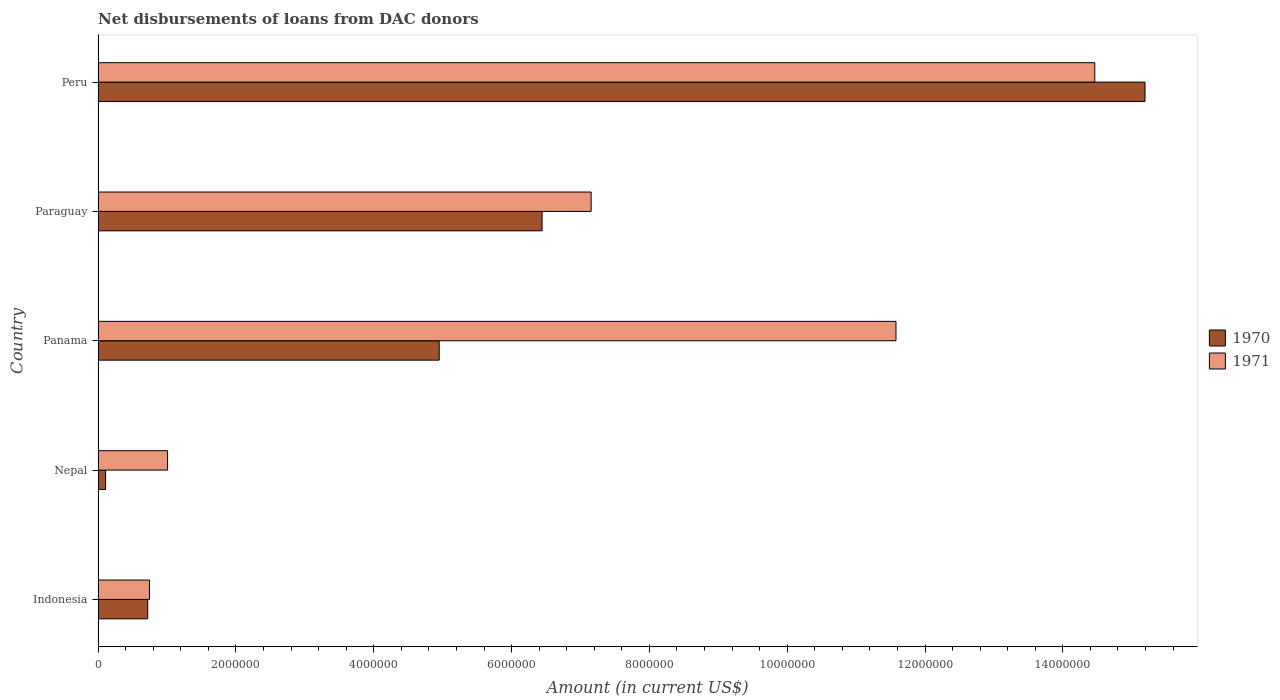How many different coloured bars are there?
Give a very brief answer. 2. Are the number of bars per tick equal to the number of legend labels?
Your response must be concise. Yes. How many bars are there on the 1st tick from the bottom?
Keep it short and to the point. 2. What is the label of the 3rd group of bars from the top?
Make the answer very short. Panama. In how many cases, is the number of bars for a given country not equal to the number of legend labels?
Your response must be concise. 0. What is the amount of loans disbursed in 1970 in Peru?
Give a very brief answer. 1.52e+07. Across all countries, what is the maximum amount of loans disbursed in 1970?
Your answer should be compact. 1.52e+07. Across all countries, what is the minimum amount of loans disbursed in 1971?
Make the answer very short. 7.45e+05. In which country was the amount of loans disbursed in 1971 minimum?
Offer a terse response. Indonesia. What is the total amount of loans disbursed in 1970 in the graph?
Offer a very short reply. 2.74e+07. What is the difference between the amount of loans disbursed in 1971 in Nepal and that in Paraguay?
Provide a succinct answer. -6.15e+06. What is the difference between the amount of loans disbursed in 1970 in Indonesia and the amount of loans disbursed in 1971 in Peru?
Ensure brevity in your answer.  -1.37e+07. What is the average amount of loans disbursed in 1970 per country?
Provide a short and direct response. 5.48e+06. What is the difference between the amount of loans disbursed in 1970 and amount of loans disbursed in 1971 in Nepal?
Offer a terse response. -8.99e+05. In how many countries, is the amount of loans disbursed in 1970 greater than 12400000 US$?
Make the answer very short. 1. What is the ratio of the amount of loans disbursed in 1970 in Indonesia to that in Paraguay?
Your answer should be very brief. 0.11. Is the amount of loans disbursed in 1971 in Nepal less than that in Panama?
Provide a succinct answer. Yes. Is the difference between the amount of loans disbursed in 1970 in Paraguay and Peru greater than the difference between the amount of loans disbursed in 1971 in Paraguay and Peru?
Your answer should be very brief. No. What is the difference between the highest and the second highest amount of loans disbursed in 1971?
Keep it short and to the point. 2.88e+06. What is the difference between the highest and the lowest amount of loans disbursed in 1971?
Provide a succinct answer. 1.37e+07. What does the 2nd bar from the bottom in Nepal represents?
Ensure brevity in your answer.  1971. Are all the bars in the graph horizontal?
Your answer should be very brief. Yes. How many countries are there in the graph?
Provide a succinct answer. 5. Are the values on the major ticks of X-axis written in scientific E-notation?
Your answer should be compact. No. Does the graph contain grids?
Offer a very short reply. No. Where does the legend appear in the graph?
Offer a terse response. Center right. How many legend labels are there?
Give a very brief answer. 2. How are the legend labels stacked?
Make the answer very short. Vertical. What is the title of the graph?
Your answer should be very brief. Net disbursements of loans from DAC donors. What is the label or title of the X-axis?
Provide a short and direct response. Amount (in current US$). What is the Amount (in current US$) of 1970 in Indonesia?
Ensure brevity in your answer.  7.20e+05. What is the Amount (in current US$) of 1971 in Indonesia?
Provide a succinct answer. 7.45e+05. What is the Amount (in current US$) of 1970 in Nepal?
Provide a succinct answer. 1.09e+05. What is the Amount (in current US$) of 1971 in Nepal?
Provide a succinct answer. 1.01e+06. What is the Amount (in current US$) in 1970 in Panama?
Your answer should be compact. 4.95e+06. What is the Amount (in current US$) of 1971 in Panama?
Offer a terse response. 1.16e+07. What is the Amount (in current US$) of 1970 in Paraguay?
Make the answer very short. 6.44e+06. What is the Amount (in current US$) in 1971 in Paraguay?
Provide a succinct answer. 7.16e+06. What is the Amount (in current US$) in 1970 in Peru?
Offer a very short reply. 1.52e+07. What is the Amount (in current US$) of 1971 in Peru?
Your response must be concise. 1.45e+07. Across all countries, what is the maximum Amount (in current US$) of 1970?
Ensure brevity in your answer.  1.52e+07. Across all countries, what is the maximum Amount (in current US$) in 1971?
Ensure brevity in your answer.  1.45e+07. Across all countries, what is the minimum Amount (in current US$) of 1970?
Make the answer very short. 1.09e+05. Across all countries, what is the minimum Amount (in current US$) in 1971?
Your response must be concise. 7.45e+05. What is the total Amount (in current US$) in 1970 in the graph?
Give a very brief answer. 2.74e+07. What is the total Amount (in current US$) of 1971 in the graph?
Provide a succinct answer. 3.50e+07. What is the difference between the Amount (in current US$) of 1970 in Indonesia and that in Nepal?
Your response must be concise. 6.11e+05. What is the difference between the Amount (in current US$) in 1971 in Indonesia and that in Nepal?
Your response must be concise. -2.63e+05. What is the difference between the Amount (in current US$) in 1970 in Indonesia and that in Panama?
Keep it short and to the point. -4.23e+06. What is the difference between the Amount (in current US$) of 1971 in Indonesia and that in Panama?
Give a very brief answer. -1.08e+07. What is the difference between the Amount (in current US$) in 1970 in Indonesia and that in Paraguay?
Offer a terse response. -5.72e+06. What is the difference between the Amount (in current US$) in 1971 in Indonesia and that in Paraguay?
Offer a terse response. -6.41e+06. What is the difference between the Amount (in current US$) in 1970 in Indonesia and that in Peru?
Offer a very short reply. -1.45e+07. What is the difference between the Amount (in current US$) of 1971 in Indonesia and that in Peru?
Provide a succinct answer. -1.37e+07. What is the difference between the Amount (in current US$) in 1970 in Nepal and that in Panama?
Make the answer very short. -4.84e+06. What is the difference between the Amount (in current US$) of 1971 in Nepal and that in Panama?
Your answer should be compact. -1.06e+07. What is the difference between the Amount (in current US$) in 1970 in Nepal and that in Paraguay?
Your response must be concise. -6.33e+06. What is the difference between the Amount (in current US$) of 1971 in Nepal and that in Paraguay?
Provide a succinct answer. -6.15e+06. What is the difference between the Amount (in current US$) in 1970 in Nepal and that in Peru?
Provide a succinct answer. -1.51e+07. What is the difference between the Amount (in current US$) in 1971 in Nepal and that in Peru?
Offer a terse response. -1.35e+07. What is the difference between the Amount (in current US$) in 1970 in Panama and that in Paraguay?
Ensure brevity in your answer.  -1.49e+06. What is the difference between the Amount (in current US$) of 1971 in Panama and that in Paraguay?
Offer a terse response. 4.42e+06. What is the difference between the Amount (in current US$) in 1970 in Panama and that in Peru?
Provide a short and direct response. -1.02e+07. What is the difference between the Amount (in current US$) of 1971 in Panama and that in Peru?
Make the answer very short. -2.88e+06. What is the difference between the Amount (in current US$) of 1970 in Paraguay and that in Peru?
Give a very brief answer. -8.75e+06. What is the difference between the Amount (in current US$) in 1971 in Paraguay and that in Peru?
Offer a terse response. -7.31e+06. What is the difference between the Amount (in current US$) of 1970 in Indonesia and the Amount (in current US$) of 1971 in Nepal?
Provide a succinct answer. -2.88e+05. What is the difference between the Amount (in current US$) of 1970 in Indonesia and the Amount (in current US$) of 1971 in Panama?
Your answer should be very brief. -1.09e+07. What is the difference between the Amount (in current US$) in 1970 in Indonesia and the Amount (in current US$) in 1971 in Paraguay?
Offer a terse response. -6.44e+06. What is the difference between the Amount (in current US$) in 1970 in Indonesia and the Amount (in current US$) in 1971 in Peru?
Provide a short and direct response. -1.37e+07. What is the difference between the Amount (in current US$) in 1970 in Nepal and the Amount (in current US$) in 1971 in Panama?
Keep it short and to the point. -1.15e+07. What is the difference between the Amount (in current US$) in 1970 in Nepal and the Amount (in current US$) in 1971 in Paraguay?
Make the answer very short. -7.05e+06. What is the difference between the Amount (in current US$) in 1970 in Nepal and the Amount (in current US$) in 1971 in Peru?
Give a very brief answer. -1.44e+07. What is the difference between the Amount (in current US$) of 1970 in Panama and the Amount (in current US$) of 1971 in Paraguay?
Offer a very short reply. -2.20e+06. What is the difference between the Amount (in current US$) of 1970 in Panama and the Amount (in current US$) of 1971 in Peru?
Offer a terse response. -9.51e+06. What is the difference between the Amount (in current US$) of 1970 in Paraguay and the Amount (in current US$) of 1971 in Peru?
Ensure brevity in your answer.  -8.02e+06. What is the average Amount (in current US$) in 1970 per country?
Your answer should be compact. 5.48e+06. What is the average Amount (in current US$) of 1971 per country?
Make the answer very short. 6.99e+06. What is the difference between the Amount (in current US$) in 1970 and Amount (in current US$) in 1971 in Indonesia?
Your answer should be compact. -2.50e+04. What is the difference between the Amount (in current US$) in 1970 and Amount (in current US$) in 1971 in Nepal?
Keep it short and to the point. -8.99e+05. What is the difference between the Amount (in current US$) of 1970 and Amount (in current US$) of 1971 in Panama?
Your response must be concise. -6.63e+06. What is the difference between the Amount (in current US$) in 1970 and Amount (in current US$) in 1971 in Paraguay?
Your answer should be very brief. -7.12e+05. What is the difference between the Amount (in current US$) of 1970 and Amount (in current US$) of 1971 in Peru?
Your answer should be very brief. 7.29e+05. What is the ratio of the Amount (in current US$) of 1970 in Indonesia to that in Nepal?
Ensure brevity in your answer.  6.61. What is the ratio of the Amount (in current US$) of 1971 in Indonesia to that in Nepal?
Provide a short and direct response. 0.74. What is the ratio of the Amount (in current US$) in 1970 in Indonesia to that in Panama?
Provide a short and direct response. 0.15. What is the ratio of the Amount (in current US$) of 1971 in Indonesia to that in Panama?
Your answer should be very brief. 0.06. What is the ratio of the Amount (in current US$) of 1970 in Indonesia to that in Paraguay?
Your answer should be compact. 0.11. What is the ratio of the Amount (in current US$) of 1971 in Indonesia to that in Paraguay?
Your answer should be compact. 0.1. What is the ratio of the Amount (in current US$) in 1970 in Indonesia to that in Peru?
Provide a short and direct response. 0.05. What is the ratio of the Amount (in current US$) of 1971 in Indonesia to that in Peru?
Provide a short and direct response. 0.05. What is the ratio of the Amount (in current US$) of 1970 in Nepal to that in Panama?
Your answer should be very brief. 0.02. What is the ratio of the Amount (in current US$) of 1971 in Nepal to that in Panama?
Keep it short and to the point. 0.09. What is the ratio of the Amount (in current US$) of 1970 in Nepal to that in Paraguay?
Give a very brief answer. 0.02. What is the ratio of the Amount (in current US$) in 1971 in Nepal to that in Paraguay?
Offer a very short reply. 0.14. What is the ratio of the Amount (in current US$) in 1970 in Nepal to that in Peru?
Give a very brief answer. 0.01. What is the ratio of the Amount (in current US$) in 1971 in Nepal to that in Peru?
Ensure brevity in your answer.  0.07. What is the ratio of the Amount (in current US$) of 1970 in Panama to that in Paraguay?
Your answer should be very brief. 0.77. What is the ratio of the Amount (in current US$) of 1971 in Panama to that in Paraguay?
Your answer should be compact. 1.62. What is the ratio of the Amount (in current US$) of 1970 in Panama to that in Peru?
Your answer should be very brief. 0.33. What is the ratio of the Amount (in current US$) in 1971 in Panama to that in Peru?
Keep it short and to the point. 0.8. What is the ratio of the Amount (in current US$) in 1970 in Paraguay to that in Peru?
Your answer should be very brief. 0.42. What is the ratio of the Amount (in current US$) of 1971 in Paraguay to that in Peru?
Make the answer very short. 0.49. What is the difference between the highest and the second highest Amount (in current US$) of 1970?
Ensure brevity in your answer.  8.75e+06. What is the difference between the highest and the second highest Amount (in current US$) in 1971?
Offer a terse response. 2.88e+06. What is the difference between the highest and the lowest Amount (in current US$) in 1970?
Your answer should be compact. 1.51e+07. What is the difference between the highest and the lowest Amount (in current US$) in 1971?
Your answer should be compact. 1.37e+07. 